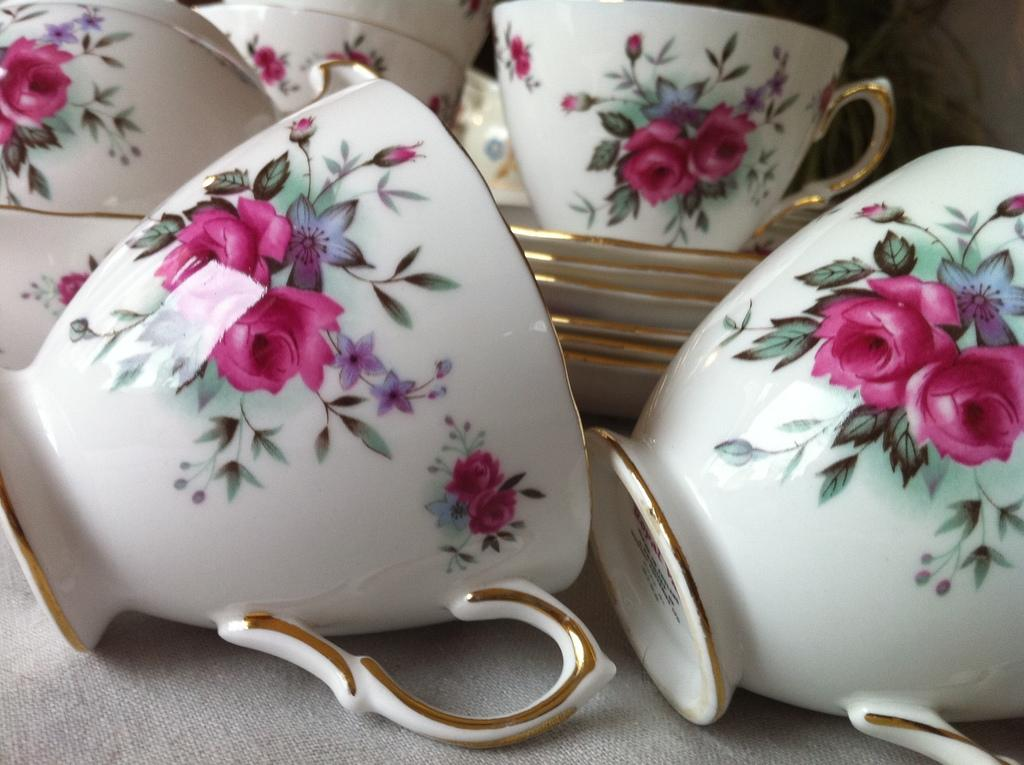What type of tableware can be seen in the image? There are cups and saucers in the image. What is the design on the cups and saucers? The design includes flowers, leaves, and buds. Are the cups and saucers plain or do they have a pattern? The cups and saucers have a design of flowers, leaves, and buds. How does the education system in the image help the cups and saucers learn? There is no education system present in the image, as it features cups and saucers with a floral design. 